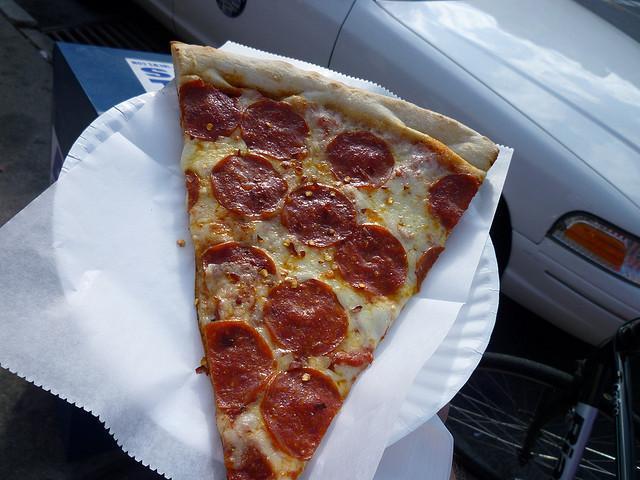Is "The pizza is on top of the bicycle." an appropriate description for the image?
Answer yes or no. No. 